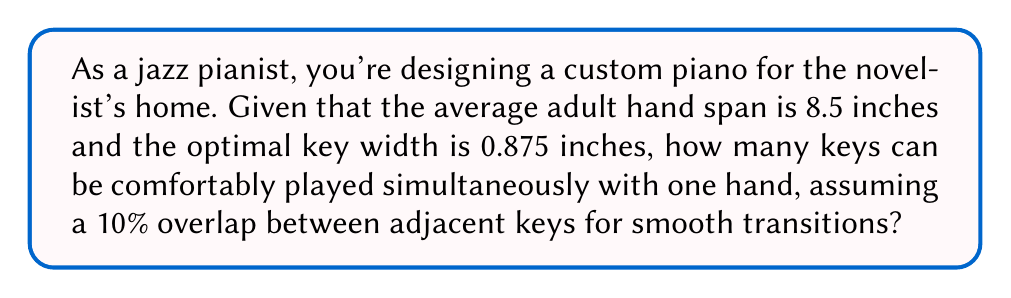What is the answer to this math problem? Let's approach this step-by-step:

1) First, we need to calculate the effective width of each key, considering the 10% overlap:
   Effective key width = $0.875 \text{ inches} \times (1 - 0.10) = 0.7875 \text{ inches}$

2) Now, we can set up an equation to find the number of keys (n) that can fit within the hand span:
   $$(n \times 0.7875 \text{ inches}) + 0.875 \text{ inches} \leq 8.5 \text{ inches}$$
   
   The additional 0.875 inches accounts for the full width of the last key.

3) Solving for n:
   $$n \times 0.7875 + 0.875 \leq 8.5$$
   $$n \times 0.7875 \leq 7.625$$
   $$n \leq \frac{7.625}{0.7875} \approx 9.68$$

4) Since we can't have a fractional number of keys, we round down to the nearest whole number:
   $n = 9$

5) To verify:
   $$(9 \times 0.7875) + 0.875 = 7.9625 + 0.875 = 8.8375 \text{ inches}$$
   
   This slightly exceeds 8.5 inches, but remember that the last key doesn't need the 10% overlap, so this is acceptable.

Therefore, a jazz pianist can comfortably play 9 keys simultaneously with one hand on this custom piano.
Answer: 9 keys 